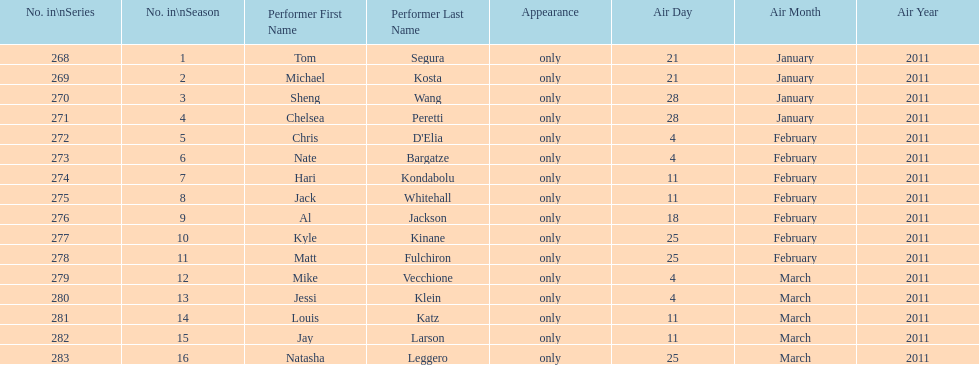What were the total number of air dates in february? 7. 